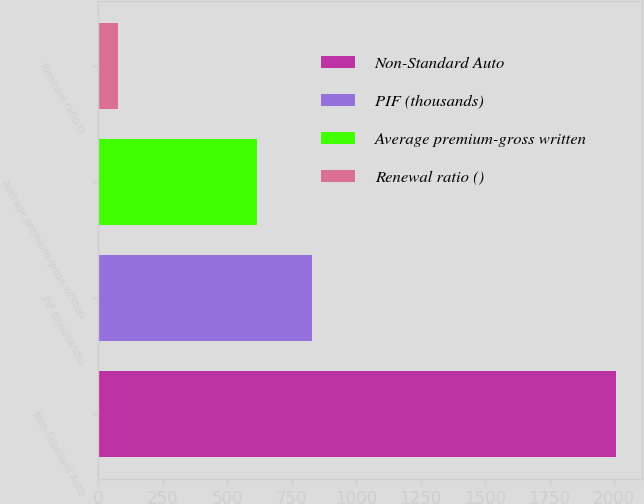<chart> <loc_0><loc_0><loc_500><loc_500><bar_chart><fcel>Non-Standard Auto<fcel>PIF (thousands)<fcel>Average premium-gross written<fcel>Renewal ratio ()<nl><fcel>2007<fcel>829<fcel>616<fcel>76.1<nl></chart> 